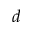<formula> <loc_0><loc_0><loc_500><loc_500>d</formula> 